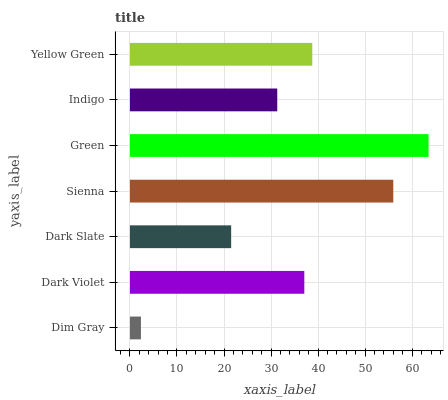Is Dim Gray the minimum?
Answer yes or no. Yes. Is Green the maximum?
Answer yes or no. Yes. Is Dark Violet the minimum?
Answer yes or no. No. Is Dark Violet the maximum?
Answer yes or no. No. Is Dark Violet greater than Dim Gray?
Answer yes or no. Yes. Is Dim Gray less than Dark Violet?
Answer yes or no. Yes. Is Dim Gray greater than Dark Violet?
Answer yes or no. No. Is Dark Violet less than Dim Gray?
Answer yes or no. No. Is Dark Violet the high median?
Answer yes or no. Yes. Is Dark Violet the low median?
Answer yes or no. Yes. Is Sienna the high median?
Answer yes or no. No. Is Green the low median?
Answer yes or no. No. 